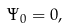<formula> <loc_0><loc_0><loc_500><loc_500>\Psi _ { 0 } = 0 ,</formula> 